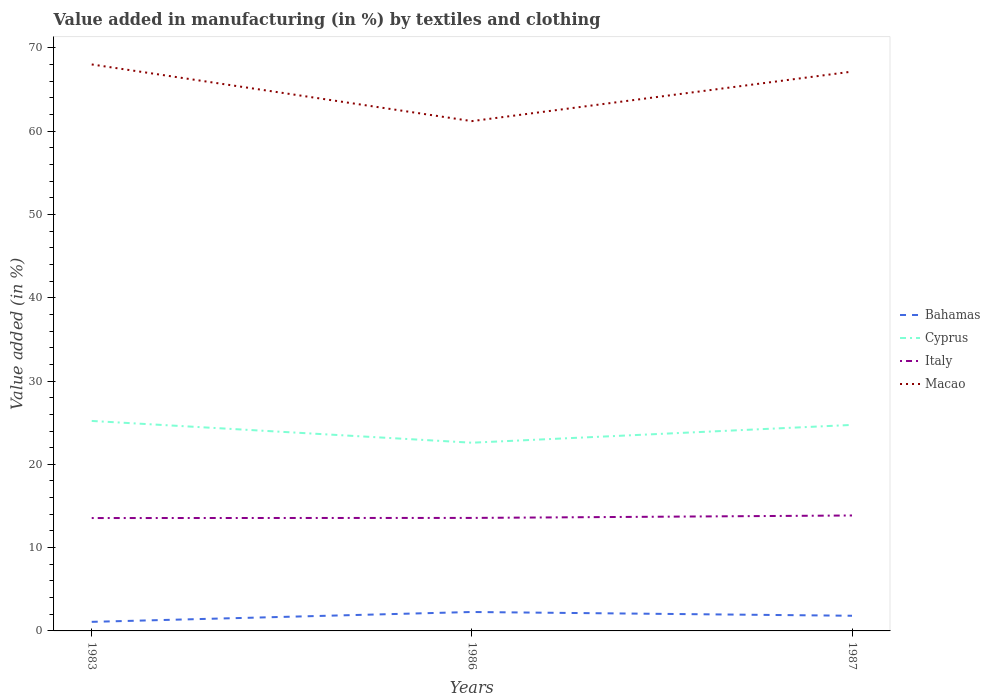Does the line corresponding to Macao intersect with the line corresponding to Bahamas?
Your answer should be compact. No. Is the number of lines equal to the number of legend labels?
Offer a terse response. Yes. Across all years, what is the maximum percentage of value added in manufacturing by textiles and clothing in Bahamas?
Give a very brief answer. 1.09. In which year was the percentage of value added in manufacturing by textiles and clothing in Italy maximum?
Offer a very short reply. 1983. What is the total percentage of value added in manufacturing by textiles and clothing in Italy in the graph?
Offer a very short reply. -0.31. What is the difference between the highest and the second highest percentage of value added in manufacturing by textiles and clothing in Bahamas?
Your answer should be very brief. 1.18. What is the difference between the highest and the lowest percentage of value added in manufacturing by textiles and clothing in Cyprus?
Keep it short and to the point. 2. Is the percentage of value added in manufacturing by textiles and clothing in Macao strictly greater than the percentage of value added in manufacturing by textiles and clothing in Bahamas over the years?
Make the answer very short. No. How many lines are there?
Your answer should be very brief. 4. What is the difference between two consecutive major ticks on the Y-axis?
Offer a very short reply. 10. Are the values on the major ticks of Y-axis written in scientific E-notation?
Your answer should be very brief. No. Does the graph contain grids?
Your response must be concise. No. Where does the legend appear in the graph?
Give a very brief answer. Center right. How many legend labels are there?
Give a very brief answer. 4. What is the title of the graph?
Your answer should be compact. Value added in manufacturing (in %) by textiles and clothing. Does "Ecuador" appear as one of the legend labels in the graph?
Keep it short and to the point. No. What is the label or title of the Y-axis?
Ensure brevity in your answer.  Value added (in %). What is the Value added (in %) of Bahamas in 1983?
Ensure brevity in your answer.  1.09. What is the Value added (in %) of Cyprus in 1983?
Offer a terse response. 25.21. What is the Value added (in %) in Italy in 1983?
Offer a very short reply. 13.55. What is the Value added (in %) of Macao in 1983?
Provide a short and direct response. 68.01. What is the Value added (in %) in Bahamas in 1986?
Keep it short and to the point. 2.27. What is the Value added (in %) in Cyprus in 1986?
Keep it short and to the point. 22.6. What is the Value added (in %) in Italy in 1986?
Offer a terse response. 13.57. What is the Value added (in %) in Macao in 1986?
Make the answer very short. 61.21. What is the Value added (in %) of Bahamas in 1987?
Your response must be concise. 1.82. What is the Value added (in %) of Cyprus in 1987?
Provide a succinct answer. 24.73. What is the Value added (in %) of Italy in 1987?
Your answer should be compact. 13.86. What is the Value added (in %) in Macao in 1987?
Your response must be concise. 67.15. Across all years, what is the maximum Value added (in %) in Bahamas?
Give a very brief answer. 2.27. Across all years, what is the maximum Value added (in %) of Cyprus?
Your answer should be very brief. 25.21. Across all years, what is the maximum Value added (in %) in Italy?
Your answer should be very brief. 13.86. Across all years, what is the maximum Value added (in %) in Macao?
Keep it short and to the point. 68.01. Across all years, what is the minimum Value added (in %) of Bahamas?
Your answer should be compact. 1.09. Across all years, what is the minimum Value added (in %) in Cyprus?
Make the answer very short. 22.6. Across all years, what is the minimum Value added (in %) in Italy?
Your answer should be compact. 13.55. Across all years, what is the minimum Value added (in %) in Macao?
Your answer should be compact. 61.21. What is the total Value added (in %) in Bahamas in the graph?
Your answer should be compact. 5.18. What is the total Value added (in %) in Cyprus in the graph?
Your answer should be compact. 72.54. What is the total Value added (in %) of Italy in the graph?
Offer a terse response. 40.98. What is the total Value added (in %) of Macao in the graph?
Provide a succinct answer. 196.37. What is the difference between the Value added (in %) in Bahamas in 1983 and that in 1986?
Offer a very short reply. -1.18. What is the difference between the Value added (in %) in Cyprus in 1983 and that in 1986?
Keep it short and to the point. 2.61. What is the difference between the Value added (in %) of Italy in 1983 and that in 1986?
Your answer should be very brief. -0.01. What is the difference between the Value added (in %) in Macao in 1983 and that in 1986?
Your answer should be compact. 6.8. What is the difference between the Value added (in %) in Bahamas in 1983 and that in 1987?
Provide a succinct answer. -0.73. What is the difference between the Value added (in %) in Cyprus in 1983 and that in 1987?
Ensure brevity in your answer.  0.48. What is the difference between the Value added (in %) in Italy in 1983 and that in 1987?
Your answer should be very brief. -0.31. What is the difference between the Value added (in %) of Macao in 1983 and that in 1987?
Make the answer very short. 0.86. What is the difference between the Value added (in %) in Bahamas in 1986 and that in 1987?
Your answer should be compact. 0.45. What is the difference between the Value added (in %) in Cyprus in 1986 and that in 1987?
Your answer should be compact. -2.14. What is the difference between the Value added (in %) of Italy in 1986 and that in 1987?
Your answer should be very brief. -0.29. What is the difference between the Value added (in %) in Macao in 1986 and that in 1987?
Ensure brevity in your answer.  -5.94. What is the difference between the Value added (in %) in Bahamas in 1983 and the Value added (in %) in Cyprus in 1986?
Provide a succinct answer. -21.51. What is the difference between the Value added (in %) of Bahamas in 1983 and the Value added (in %) of Italy in 1986?
Give a very brief answer. -12.48. What is the difference between the Value added (in %) in Bahamas in 1983 and the Value added (in %) in Macao in 1986?
Make the answer very short. -60.12. What is the difference between the Value added (in %) in Cyprus in 1983 and the Value added (in %) in Italy in 1986?
Your answer should be very brief. 11.64. What is the difference between the Value added (in %) in Cyprus in 1983 and the Value added (in %) in Macao in 1986?
Give a very brief answer. -36. What is the difference between the Value added (in %) of Italy in 1983 and the Value added (in %) of Macao in 1986?
Your answer should be very brief. -47.65. What is the difference between the Value added (in %) of Bahamas in 1983 and the Value added (in %) of Cyprus in 1987?
Offer a terse response. -23.64. What is the difference between the Value added (in %) in Bahamas in 1983 and the Value added (in %) in Italy in 1987?
Your response must be concise. -12.77. What is the difference between the Value added (in %) in Bahamas in 1983 and the Value added (in %) in Macao in 1987?
Keep it short and to the point. -66.06. What is the difference between the Value added (in %) in Cyprus in 1983 and the Value added (in %) in Italy in 1987?
Offer a terse response. 11.35. What is the difference between the Value added (in %) of Cyprus in 1983 and the Value added (in %) of Macao in 1987?
Offer a terse response. -41.94. What is the difference between the Value added (in %) of Italy in 1983 and the Value added (in %) of Macao in 1987?
Your answer should be very brief. -53.6. What is the difference between the Value added (in %) of Bahamas in 1986 and the Value added (in %) of Cyprus in 1987?
Your answer should be compact. -22.46. What is the difference between the Value added (in %) of Bahamas in 1986 and the Value added (in %) of Italy in 1987?
Your response must be concise. -11.59. What is the difference between the Value added (in %) of Bahamas in 1986 and the Value added (in %) of Macao in 1987?
Your answer should be compact. -64.88. What is the difference between the Value added (in %) of Cyprus in 1986 and the Value added (in %) of Italy in 1987?
Provide a short and direct response. 8.74. What is the difference between the Value added (in %) of Cyprus in 1986 and the Value added (in %) of Macao in 1987?
Offer a very short reply. -44.55. What is the difference between the Value added (in %) of Italy in 1986 and the Value added (in %) of Macao in 1987?
Your answer should be compact. -53.58. What is the average Value added (in %) of Bahamas per year?
Your answer should be compact. 1.73. What is the average Value added (in %) in Cyprus per year?
Offer a very short reply. 24.18. What is the average Value added (in %) in Italy per year?
Keep it short and to the point. 13.66. What is the average Value added (in %) of Macao per year?
Give a very brief answer. 65.46. In the year 1983, what is the difference between the Value added (in %) in Bahamas and Value added (in %) in Cyprus?
Offer a terse response. -24.12. In the year 1983, what is the difference between the Value added (in %) of Bahamas and Value added (in %) of Italy?
Offer a very short reply. -12.46. In the year 1983, what is the difference between the Value added (in %) of Bahamas and Value added (in %) of Macao?
Your response must be concise. -66.92. In the year 1983, what is the difference between the Value added (in %) of Cyprus and Value added (in %) of Italy?
Provide a short and direct response. 11.66. In the year 1983, what is the difference between the Value added (in %) of Cyprus and Value added (in %) of Macao?
Your response must be concise. -42.8. In the year 1983, what is the difference between the Value added (in %) of Italy and Value added (in %) of Macao?
Keep it short and to the point. -54.46. In the year 1986, what is the difference between the Value added (in %) in Bahamas and Value added (in %) in Cyprus?
Offer a terse response. -20.32. In the year 1986, what is the difference between the Value added (in %) in Bahamas and Value added (in %) in Italy?
Your answer should be compact. -11.29. In the year 1986, what is the difference between the Value added (in %) of Bahamas and Value added (in %) of Macao?
Provide a succinct answer. -58.93. In the year 1986, what is the difference between the Value added (in %) of Cyprus and Value added (in %) of Italy?
Provide a short and direct response. 9.03. In the year 1986, what is the difference between the Value added (in %) of Cyprus and Value added (in %) of Macao?
Your answer should be very brief. -38.61. In the year 1986, what is the difference between the Value added (in %) of Italy and Value added (in %) of Macao?
Your answer should be compact. -47.64. In the year 1987, what is the difference between the Value added (in %) in Bahamas and Value added (in %) in Cyprus?
Your answer should be very brief. -22.91. In the year 1987, what is the difference between the Value added (in %) of Bahamas and Value added (in %) of Italy?
Provide a succinct answer. -12.04. In the year 1987, what is the difference between the Value added (in %) of Bahamas and Value added (in %) of Macao?
Offer a very short reply. -65.33. In the year 1987, what is the difference between the Value added (in %) of Cyprus and Value added (in %) of Italy?
Your answer should be compact. 10.87. In the year 1987, what is the difference between the Value added (in %) of Cyprus and Value added (in %) of Macao?
Offer a very short reply. -42.42. In the year 1987, what is the difference between the Value added (in %) in Italy and Value added (in %) in Macao?
Provide a succinct answer. -53.29. What is the ratio of the Value added (in %) in Bahamas in 1983 to that in 1986?
Provide a short and direct response. 0.48. What is the ratio of the Value added (in %) in Cyprus in 1983 to that in 1986?
Give a very brief answer. 1.12. What is the ratio of the Value added (in %) in Italy in 1983 to that in 1986?
Offer a very short reply. 1. What is the ratio of the Value added (in %) of Macao in 1983 to that in 1986?
Provide a short and direct response. 1.11. What is the ratio of the Value added (in %) of Bahamas in 1983 to that in 1987?
Provide a succinct answer. 0.6. What is the ratio of the Value added (in %) of Cyprus in 1983 to that in 1987?
Make the answer very short. 1.02. What is the ratio of the Value added (in %) in Italy in 1983 to that in 1987?
Give a very brief answer. 0.98. What is the ratio of the Value added (in %) of Macao in 1983 to that in 1987?
Your answer should be very brief. 1.01. What is the ratio of the Value added (in %) of Bahamas in 1986 to that in 1987?
Keep it short and to the point. 1.25. What is the ratio of the Value added (in %) in Cyprus in 1986 to that in 1987?
Ensure brevity in your answer.  0.91. What is the ratio of the Value added (in %) of Italy in 1986 to that in 1987?
Give a very brief answer. 0.98. What is the ratio of the Value added (in %) of Macao in 1986 to that in 1987?
Give a very brief answer. 0.91. What is the difference between the highest and the second highest Value added (in %) of Bahamas?
Your answer should be very brief. 0.45. What is the difference between the highest and the second highest Value added (in %) in Cyprus?
Keep it short and to the point. 0.48. What is the difference between the highest and the second highest Value added (in %) in Italy?
Your response must be concise. 0.29. What is the difference between the highest and the second highest Value added (in %) in Macao?
Your response must be concise. 0.86. What is the difference between the highest and the lowest Value added (in %) of Bahamas?
Make the answer very short. 1.18. What is the difference between the highest and the lowest Value added (in %) in Cyprus?
Your answer should be compact. 2.61. What is the difference between the highest and the lowest Value added (in %) of Italy?
Your answer should be very brief. 0.31. What is the difference between the highest and the lowest Value added (in %) of Macao?
Offer a very short reply. 6.8. 